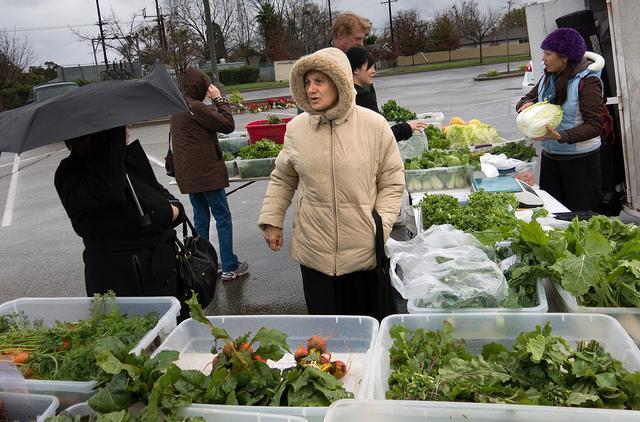How many people are there?
Give a very brief answer. 5. How many of the cows are calves?
Give a very brief answer. 0. 